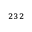Convert formula to latex. <formula><loc_0><loc_0><loc_500><loc_500>^ { 2 3 2 }</formula> 